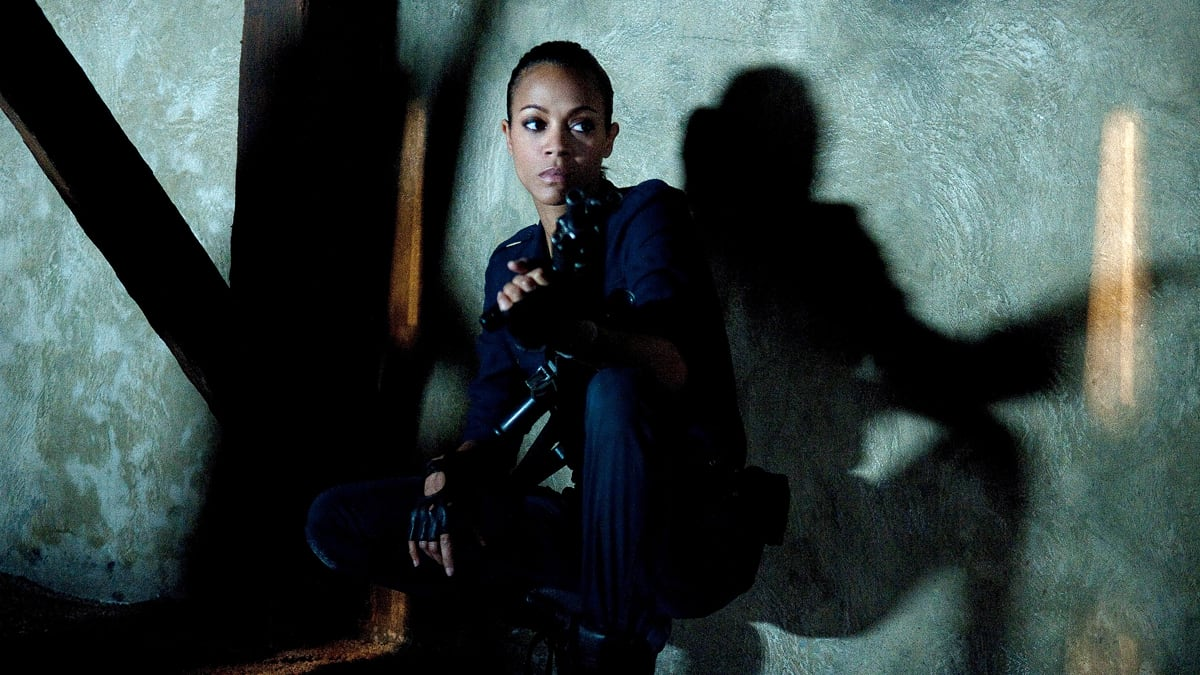What kind of setting do you think this scene takes place in? Describe the environment. This scene appears to be set in a sparse, poorly lit room that suggests a covert or concealed location, such as a safehouse or a hideout. The rough textures on the walls and the minimalistic setting emphasize a clandestine, almost desolate atmosphere. 